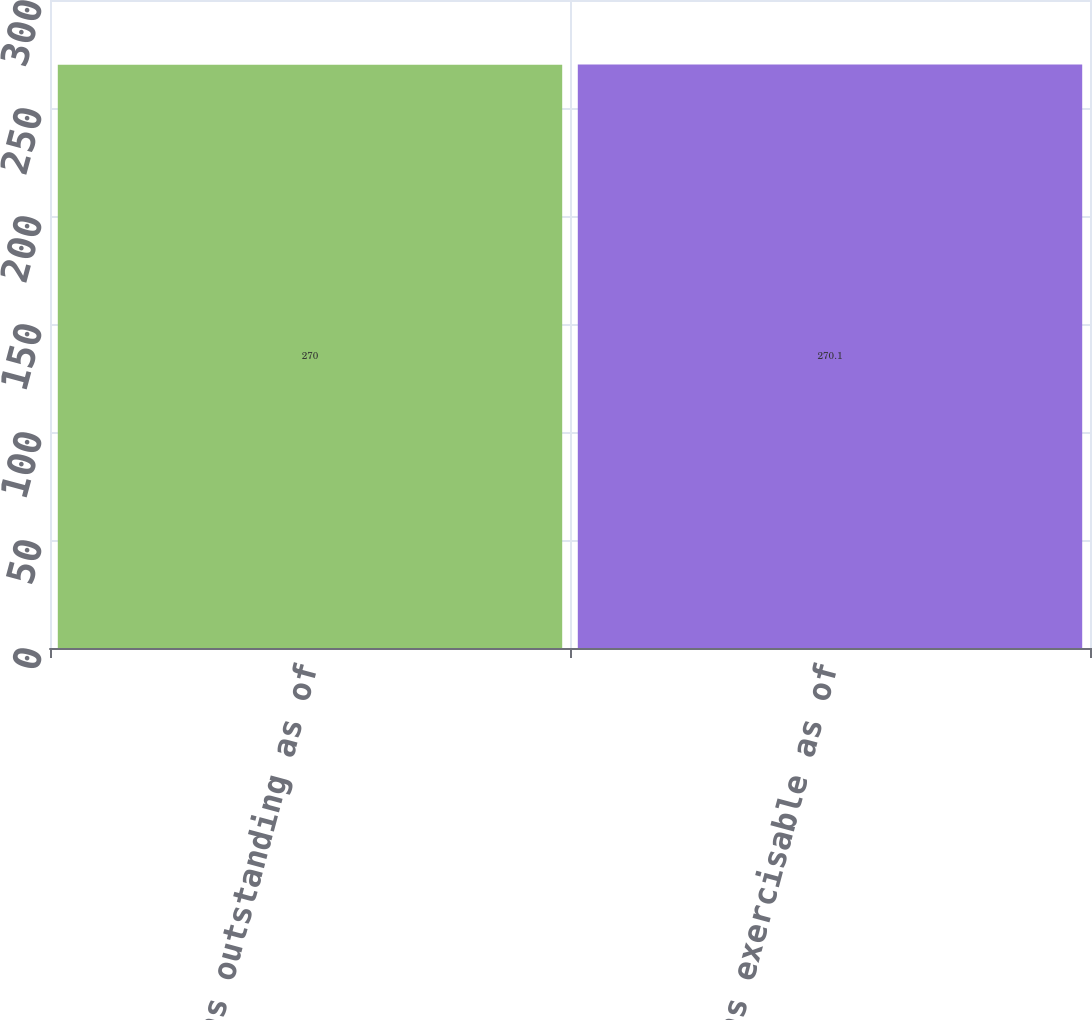<chart> <loc_0><loc_0><loc_500><loc_500><bar_chart><fcel>Options outstanding as of<fcel>Options exercisable as of<nl><fcel>270<fcel>270.1<nl></chart> 